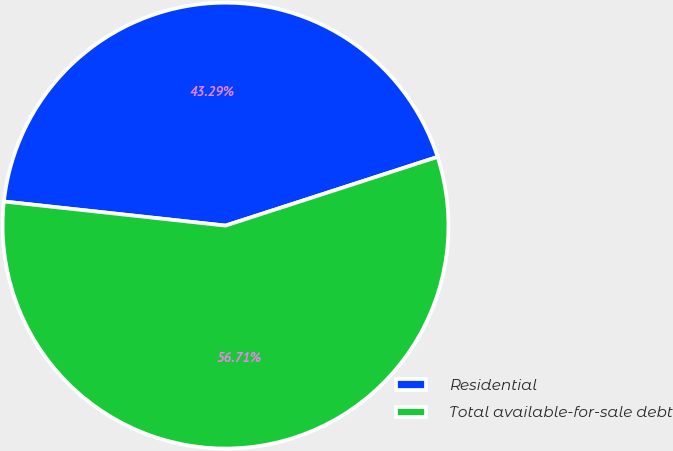Convert chart. <chart><loc_0><loc_0><loc_500><loc_500><pie_chart><fcel>Residential<fcel>Total available-for-sale debt<nl><fcel>43.29%<fcel>56.71%<nl></chart> 